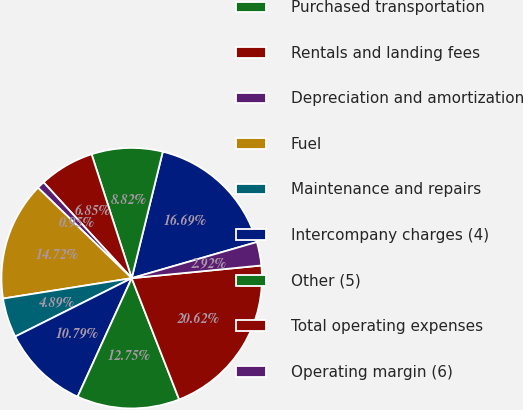Convert chart. <chart><loc_0><loc_0><loc_500><loc_500><pie_chart><fcel>Salaries and employee benefits<fcel>Purchased transportation<fcel>Rentals and landing fees<fcel>Depreciation and amortization<fcel>Fuel<fcel>Maintenance and repairs<fcel>Intercompany charges (4)<fcel>Other (5)<fcel>Total operating expenses<fcel>Operating margin (6)<nl><fcel>16.69%<fcel>8.82%<fcel>6.85%<fcel>0.95%<fcel>14.72%<fcel>4.89%<fcel>10.79%<fcel>12.75%<fcel>20.62%<fcel>2.92%<nl></chart> 